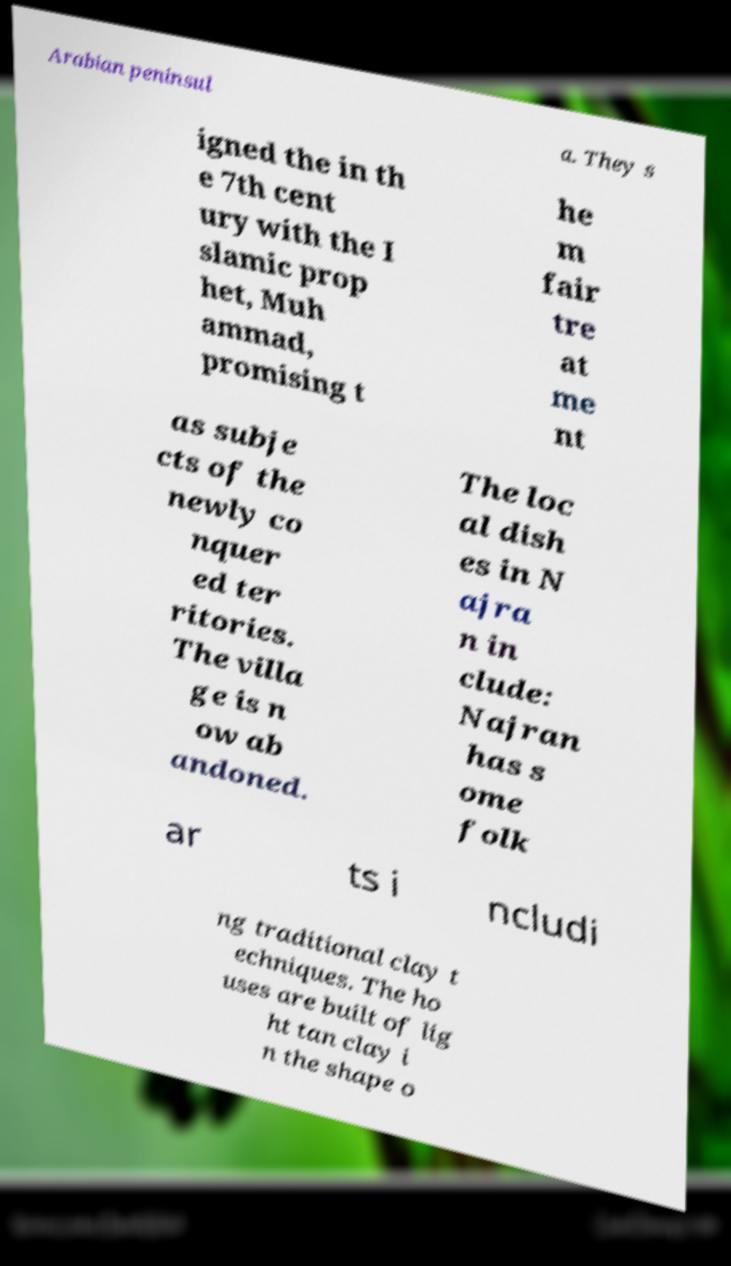Could you extract and type out the text from this image? Arabian peninsul a. They s igned the in th e 7th cent ury with the I slamic prop het, Muh ammad, promising t he m fair tre at me nt as subje cts of the newly co nquer ed ter ritories. The villa ge is n ow ab andoned. The loc al dish es in N ajra n in clude: Najran has s ome folk ar ts i ncludi ng traditional clay t echniques. The ho uses are built of lig ht tan clay i n the shape o 